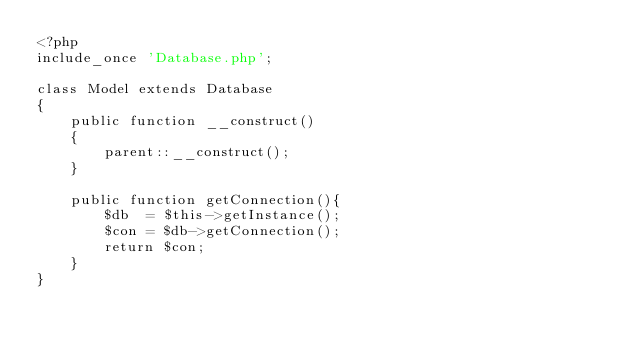<code> <loc_0><loc_0><loc_500><loc_500><_PHP_><?php
include_once 'Database.php';

class Model extends Database
{
    public function __construct()
    {
        parent::__construct();
    }

    public function getConnection(){
        $db  = $this->getInstance();
        $con = $db->getConnection();
        return $con;
    }
}</code> 